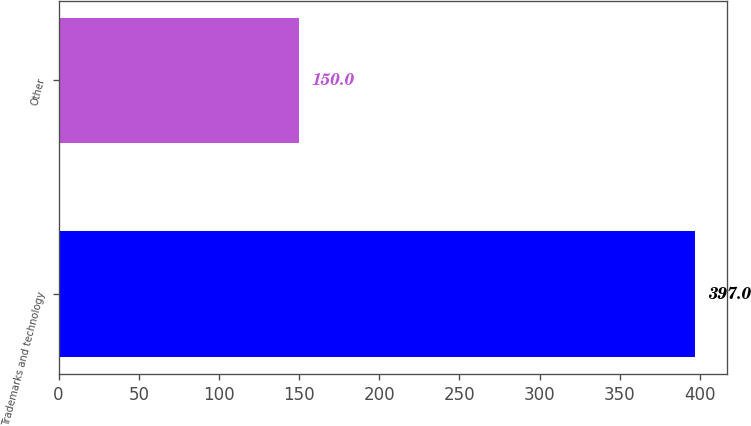Convert chart to OTSL. <chart><loc_0><loc_0><loc_500><loc_500><bar_chart><fcel>Trademarks and technology<fcel>Other<nl><fcel>397<fcel>150<nl></chart> 